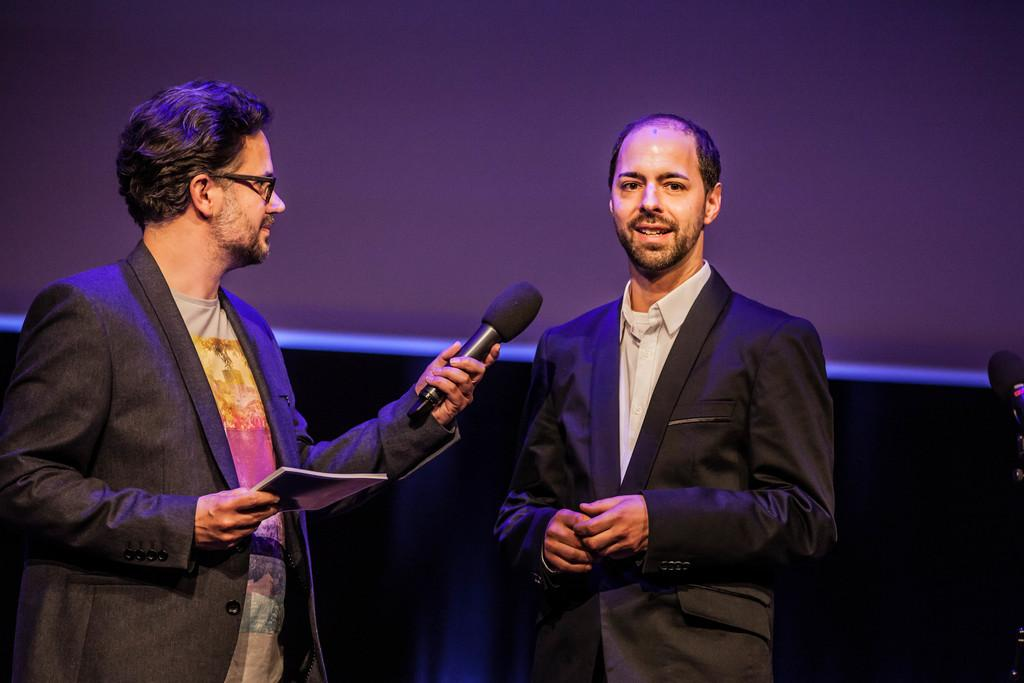How many people are in the image? There are two persons in the image. What are the people wearing? Both persons are wearing black suits. Can you describe any objects that one of the persons is holding? One person is holding a microphone in his hand. Is there anything visible on the left side of one of the persons? Yes, one person has a book on the left side. What type of sand can be seen in the image? There is no sand present in the image. How does the decision-making process appear to be going between the two persons in the image? The provided facts do not mention any decision-making process or interaction between the two persons, so it cannot be determined from the image. 